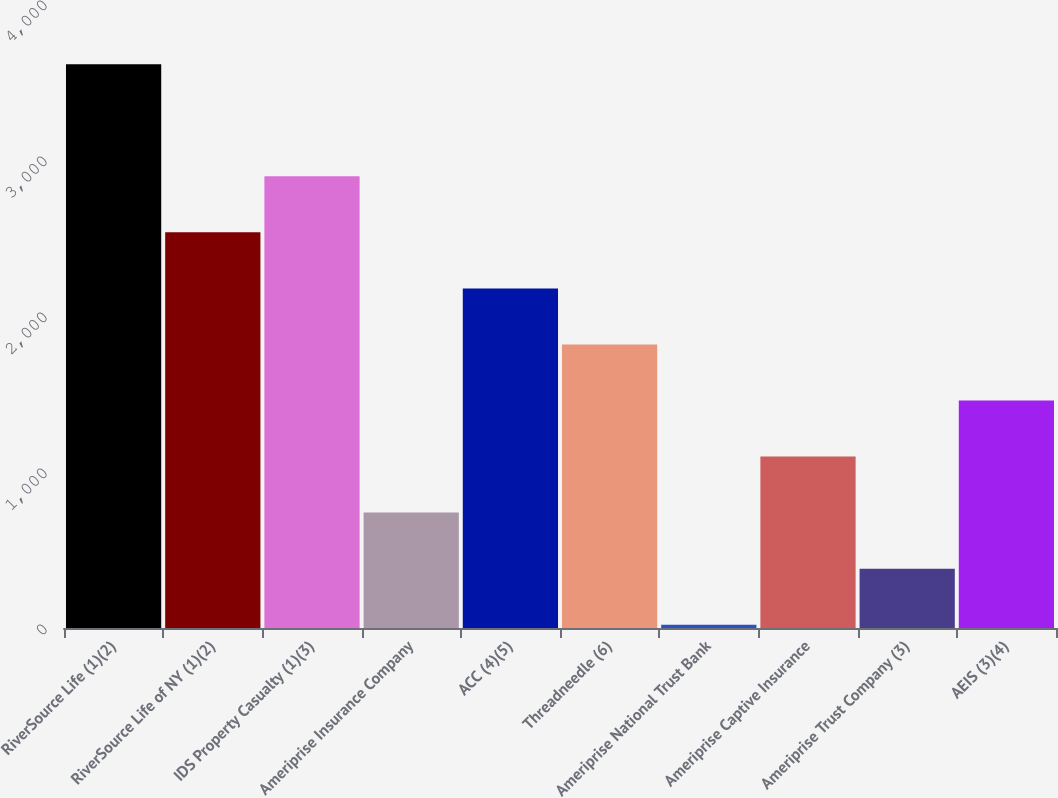Convert chart. <chart><loc_0><loc_0><loc_500><loc_500><bar_chart><fcel>RiverSource Life (1)(2)<fcel>RiverSource Life of NY (1)(2)<fcel>IDS Property Casualty (1)(3)<fcel>Ameriprise Insurance Company<fcel>ACC (4)(5)<fcel>Threadneedle (6)<fcel>Ameriprise National Trust Bank<fcel>Ameriprise Captive Insurance<fcel>Ameriprise Trust Company (3)<fcel>AEIS (3)(4)<nl><fcel>3614<fcel>2536.1<fcel>2895.4<fcel>739.6<fcel>2176.8<fcel>1817.5<fcel>21<fcel>1098.9<fcel>380.3<fcel>1458.2<nl></chart> 